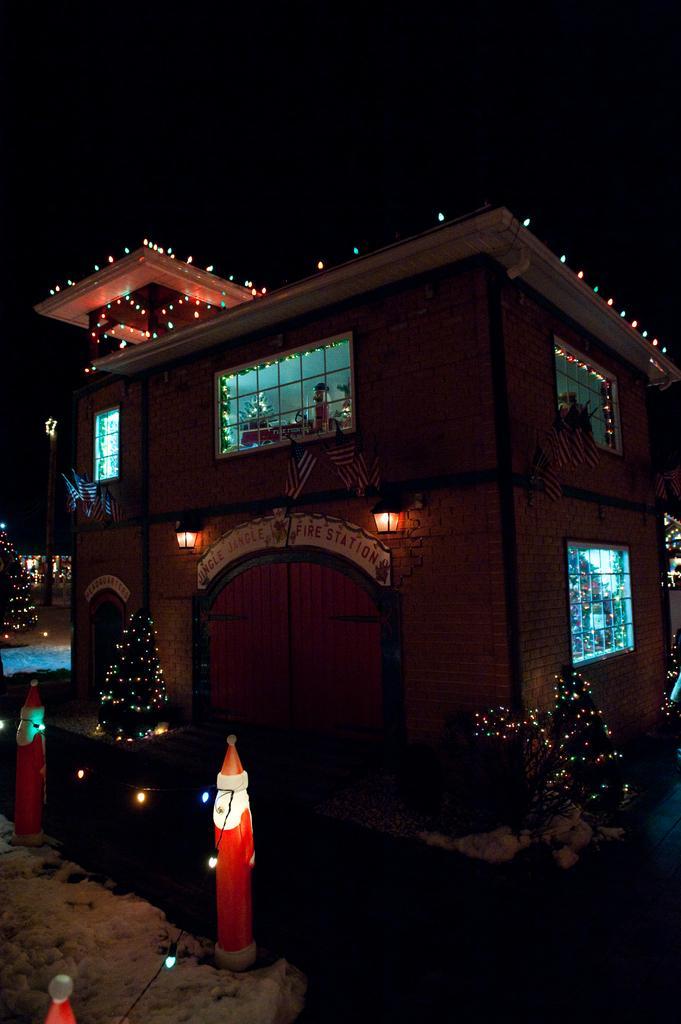Can you describe this image briefly? In the picture I can see the poles, Xmas trees decorated with lights, I can see a house, glass windows, snow on the left side of the image and the dark sky in the background. 